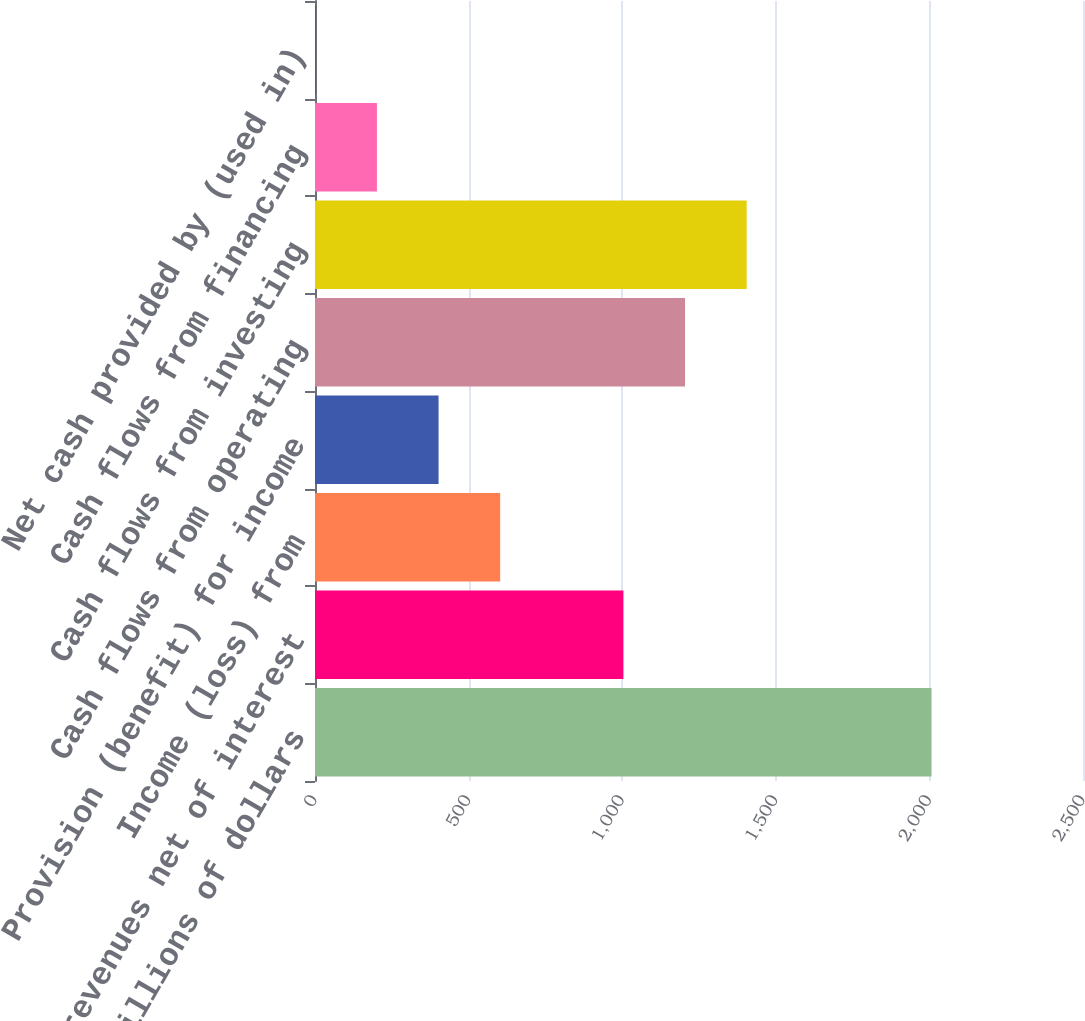Convert chart to OTSL. <chart><loc_0><loc_0><loc_500><loc_500><bar_chart><fcel>In millions of dollars<fcel>Total revenues net of interest<fcel>Income (loss) from<fcel>Provision (benefit) for income<fcel>Cash flows from operating<fcel>Cash flows from investing<fcel>Cash flows from financing<fcel>Net cash provided by (used in)<nl><fcel>2007<fcel>1004<fcel>602.8<fcel>402.2<fcel>1204.6<fcel>1405.2<fcel>201.6<fcel>1<nl></chart> 